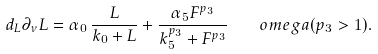Convert formula to latex. <formula><loc_0><loc_0><loc_500><loc_500>d _ { L } \partial _ { \nu } L = \alpha _ { 0 } \, \frac { L } { k _ { 0 } + L } + \frac { \alpha _ { 5 } F ^ { p _ { 3 } } } { k _ { 5 } ^ { p _ { 3 } } + F ^ { p _ { 3 } } } \quad o m e g a ( p _ { 3 } > 1 ) .</formula> 